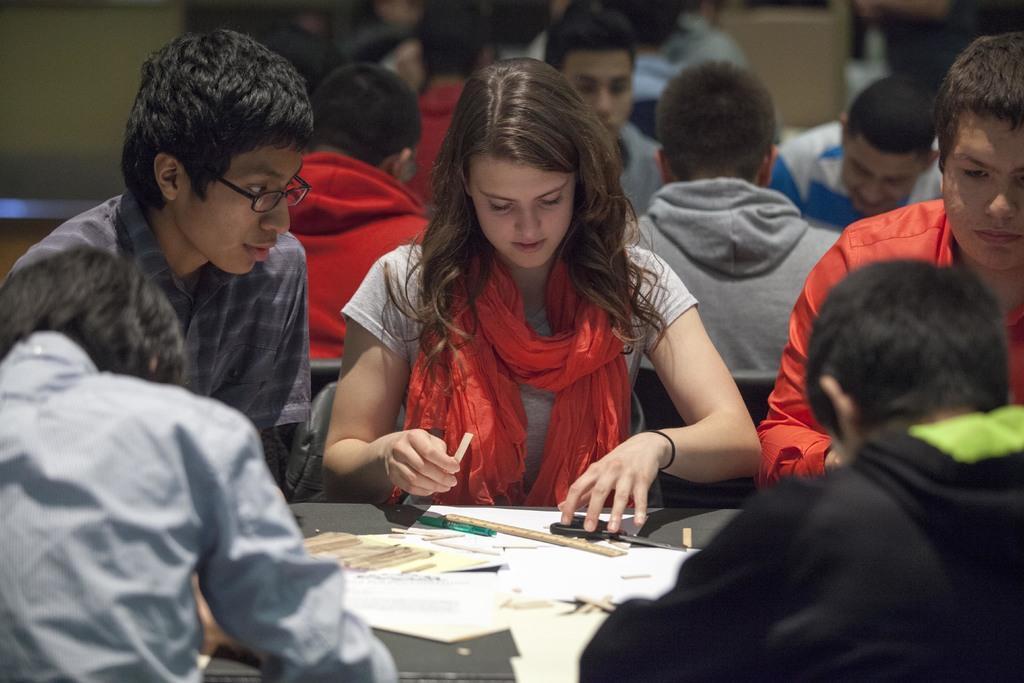Can you describe this image briefly? Hear I can see few people are sitting on the chairs around the table. On the table there are some papers, a cutter, pen and a scale. The woman who is sitting in the middle is looking at the paper which is in front of her. In the background, I can see many people are also sitting on the chairs. On the top of the image there is a wall. 